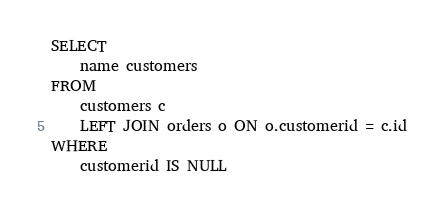Convert code to text. <code><loc_0><loc_0><loc_500><loc_500><_SQL_>SELECT
    name customers
FROM
    customers c
    LEFT JOIN orders o ON o.customerid = c.id
WHERE
    customerid IS NULL
</code> 